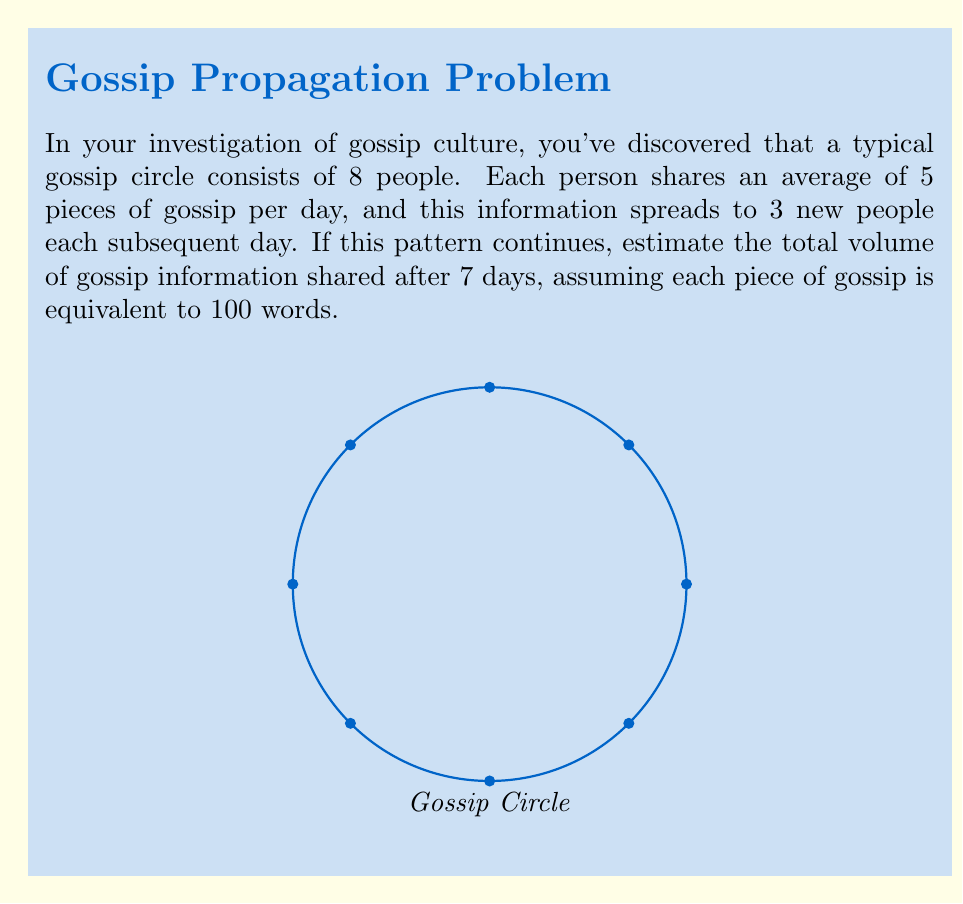Teach me how to tackle this problem. Let's break this down step-by-step:

1) Initial gossip on day 1:
   $$ 8 \text{ people} \times 5 \text{ pieces} = 40 \text{ pieces} $$

2) For each subsequent day, the gossip spreads to 3 new people:
   $$ \text{Day 2}: 40 \times 3 = 120 \text{ new pieces} $$
   $$ \text{Day 3}: 120 \times 3 = 360 \text{ new pieces} $$
   $$ \text{Day 4}: 360 \times 3 = 1,080 \text{ new pieces} $$
   $$ \text{Day 5}: 1,080 \times 3 = 3,240 \text{ new pieces} $$
   $$ \text{Day 6}: 3,240 \times 3 = 9,720 \text{ new pieces} $$
   $$ \text{Day 7}: 9,720 \times 3 = 29,160 \text{ new pieces} $$

3) Total pieces of gossip over 7 days:
   $$ 40 + 120 + 360 + 1,080 + 3,240 + 9,720 + 29,160 = 43,720 \text{ pieces} $$

4) Convert to words:
   $$ 43,720 \text{ pieces} \times 100 \text{ words/piece} = 4,372,000 \text{ words} $$

5) Estimating volume:
   Assuming an average of 5 words per line and 40 lines per page in a standard book:
   $$ \text{Words per page} = 5 \times 40 = 200 $$
   $$ \text{Number of pages} = \frac{4,372,000}{200} = 21,860 \text{ pages} $$

   If each page is 0.1 mm thick:
   $$ \text{Total thickness} = 21,860 \times 0.1 \text{ mm} = 2,186 \text{ mm} = 2.186 \text{ m} $$

   Assuming a standard book size of 15 cm × 22 cm:
   $$ \text{Volume} = 15 \text{ cm} \times 22 \text{ cm} \times 218.6 \text{ cm} = 72,138 \text{ cm}^3 \approx 0.072 \text{ m}^3 $$
Answer: $0.072 \text{ m}^3$ 